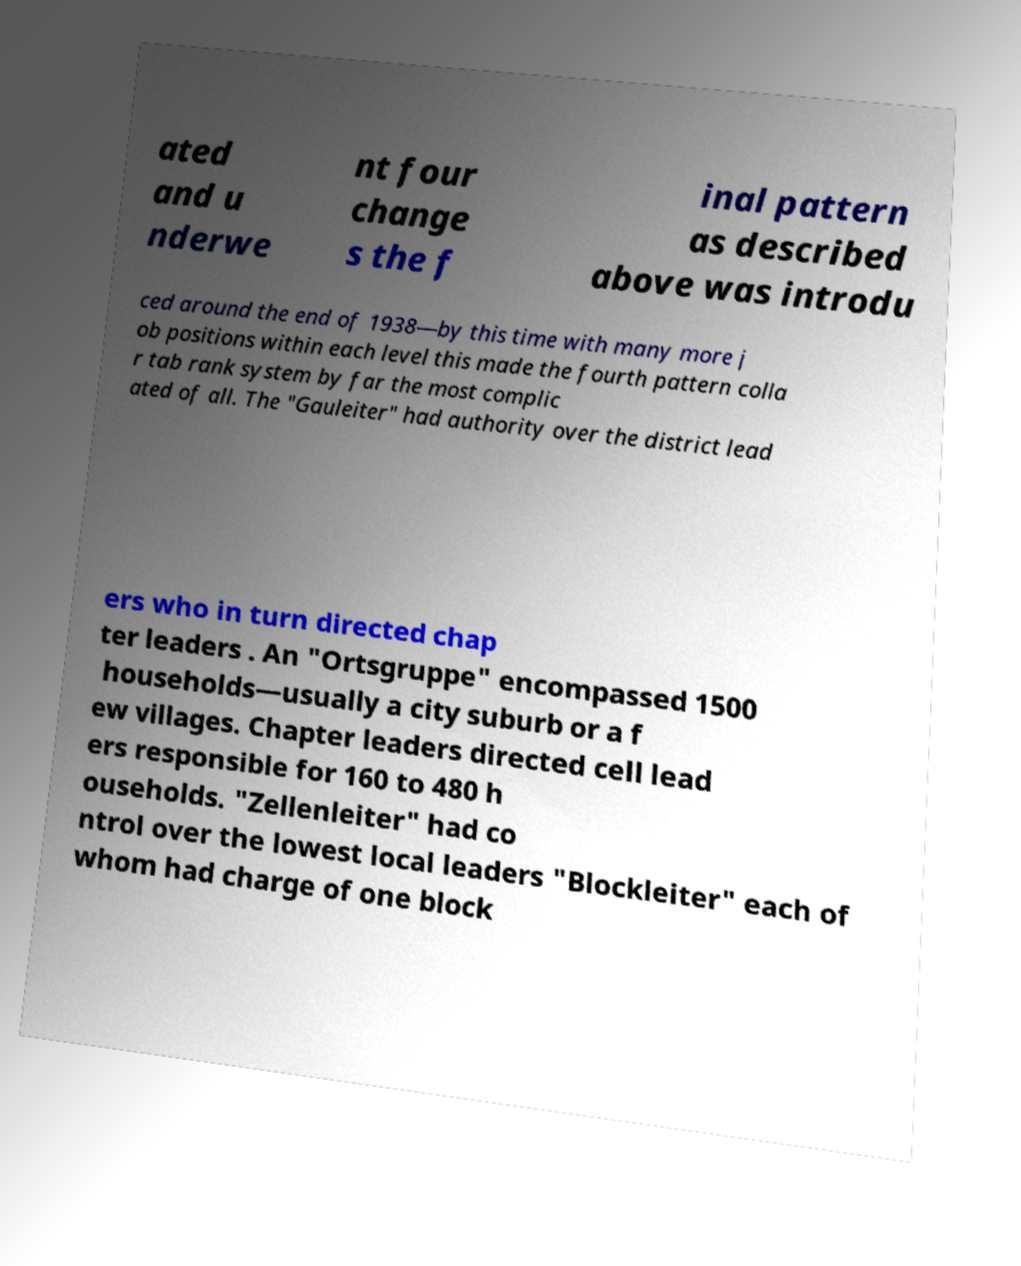Please read and relay the text visible in this image. What does it say? ated and u nderwe nt four change s the f inal pattern as described above was introdu ced around the end of 1938—by this time with many more j ob positions within each level this made the fourth pattern colla r tab rank system by far the most complic ated of all. The "Gauleiter" had authority over the district lead ers who in turn directed chap ter leaders . An "Ortsgruppe" encompassed 1500 households—usually a city suburb or a f ew villages. Chapter leaders directed cell lead ers responsible for 160 to 480 h ouseholds. "Zellenleiter" had co ntrol over the lowest local leaders "Blockleiter" each of whom had charge of one block 